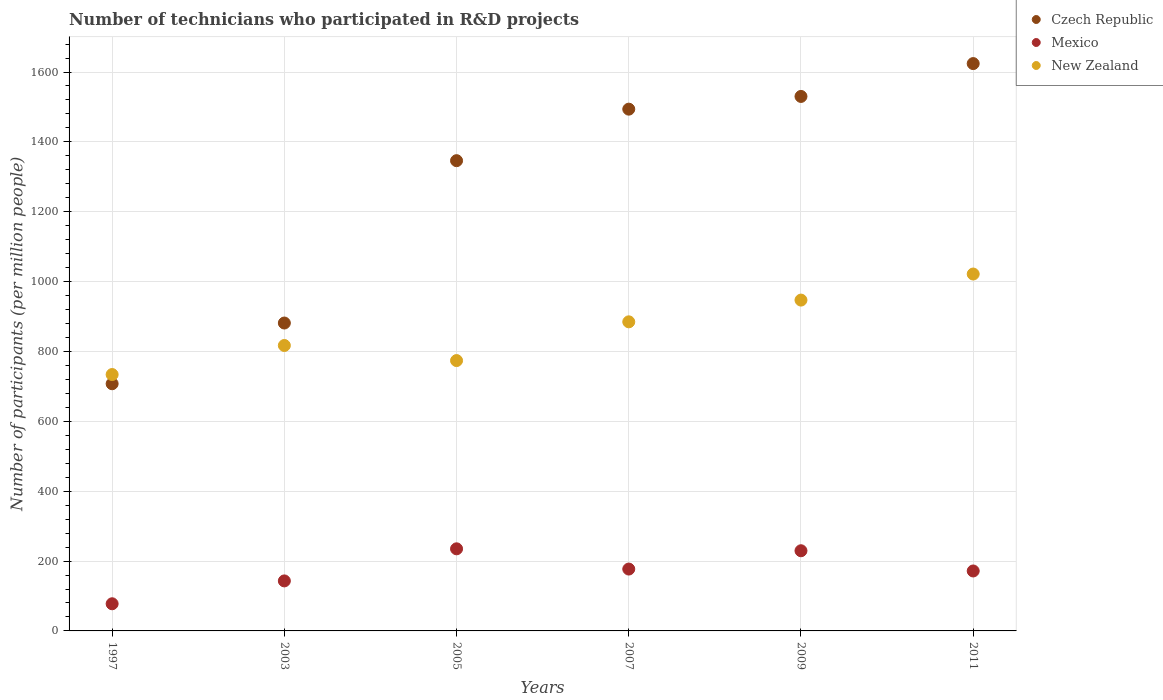Is the number of dotlines equal to the number of legend labels?
Provide a succinct answer. Yes. What is the number of technicians who participated in R&D projects in New Zealand in 1997?
Ensure brevity in your answer.  733.97. Across all years, what is the maximum number of technicians who participated in R&D projects in Czech Republic?
Your answer should be compact. 1624.14. Across all years, what is the minimum number of technicians who participated in R&D projects in Mexico?
Keep it short and to the point. 77.72. In which year was the number of technicians who participated in R&D projects in Mexico maximum?
Offer a very short reply. 2005. In which year was the number of technicians who participated in R&D projects in Czech Republic minimum?
Ensure brevity in your answer.  1997. What is the total number of technicians who participated in R&D projects in Mexico in the graph?
Make the answer very short. 1034.16. What is the difference between the number of technicians who participated in R&D projects in Czech Republic in 1997 and that in 2003?
Provide a succinct answer. -173.83. What is the difference between the number of technicians who participated in R&D projects in Mexico in 1997 and the number of technicians who participated in R&D projects in Czech Republic in 2005?
Provide a short and direct response. -1268.46. What is the average number of technicians who participated in R&D projects in Czech Republic per year?
Ensure brevity in your answer.  1263.85. In the year 2003, what is the difference between the number of technicians who participated in R&D projects in New Zealand and number of technicians who participated in R&D projects in Mexico?
Give a very brief answer. 673.95. In how many years, is the number of technicians who participated in R&D projects in New Zealand greater than 1280?
Your answer should be very brief. 0. What is the ratio of the number of technicians who participated in R&D projects in Mexico in 1997 to that in 2009?
Your response must be concise. 0.34. Is the number of technicians who participated in R&D projects in Mexico in 1997 less than that in 2011?
Give a very brief answer. Yes. What is the difference between the highest and the second highest number of technicians who participated in R&D projects in Czech Republic?
Your response must be concise. 94.04. What is the difference between the highest and the lowest number of technicians who participated in R&D projects in New Zealand?
Make the answer very short. 287.72. Is it the case that in every year, the sum of the number of technicians who participated in R&D projects in Mexico and number of technicians who participated in R&D projects in New Zealand  is greater than the number of technicians who participated in R&D projects in Czech Republic?
Provide a short and direct response. No. Is the number of technicians who participated in R&D projects in Czech Republic strictly greater than the number of technicians who participated in R&D projects in New Zealand over the years?
Offer a terse response. No. How many dotlines are there?
Make the answer very short. 3. Does the graph contain grids?
Make the answer very short. Yes. How many legend labels are there?
Your answer should be compact. 3. What is the title of the graph?
Ensure brevity in your answer.  Number of technicians who participated in R&D projects. Does "Bulgaria" appear as one of the legend labels in the graph?
Give a very brief answer. No. What is the label or title of the X-axis?
Offer a terse response. Years. What is the label or title of the Y-axis?
Make the answer very short. Number of participants (per million people). What is the Number of participants (per million people) of Czech Republic in 1997?
Your answer should be very brief. 707.59. What is the Number of participants (per million people) of Mexico in 1997?
Provide a succinct answer. 77.72. What is the Number of participants (per million people) in New Zealand in 1997?
Your response must be concise. 733.97. What is the Number of participants (per million people) of Czech Republic in 2003?
Give a very brief answer. 881.43. What is the Number of participants (per million people) in Mexico in 2003?
Make the answer very short. 143.18. What is the Number of participants (per million people) of New Zealand in 2003?
Provide a short and direct response. 817.12. What is the Number of participants (per million people) in Czech Republic in 2005?
Provide a short and direct response. 1346.19. What is the Number of participants (per million people) of Mexico in 2005?
Offer a very short reply. 235.05. What is the Number of participants (per million people) in New Zealand in 2005?
Provide a short and direct response. 773.94. What is the Number of participants (per million people) in Czech Republic in 2007?
Offer a very short reply. 1493.68. What is the Number of participants (per million people) in Mexico in 2007?
Your answer should be very brief. 177.1. What is the Number of participants (per million people) in New Zealand in 2007?
Offer a very short reply. 884.85. What is the Number of participants (per million people) of Czech Republic in 2009?
Give a very brief answer. 1530.09. What is the Number of participants (per million people) in Mexico in 2009?
Your answer should be compact. 229.5. What is the Number of participants (per million people) in New Zealand in 2009?
Keep it short and to the point. 947.07. What is the Number of participants (per million people) in Czech Republic in 2011?
Ensure brevity in your answer.  1624.14. What is the Number of participants (per million people) in Mexico in 2011?
Offer a very short reply. 171.61. What is the Number of participants (per million people) of New Zealand in 2011?
Your response must be concise. 1021.69. Across all years, what is the maximum Number of participants (per million people) of Czech Republic?
Your answer should be very brief. 1624.14. Across all years, what is the maximum Number of participants (per million people) of Mexico?
Ensure brevity in your answer.  235.05. Across all years, what is the maximum Number of participants (per million people) of New Zealand?
Your response must be concise. 1021.69. Across all years, what is the minimum Number of participants (per million people) in Czech Republic?
Offer a very short reply. 707.59. Across all years, what is the minimum Number of participants (per million people) in Mexico?
Your answer should be very brief. 77.72. Across all years, what is the minimum Number of participants (per million people) of New Zealand?
Your answer should be very brief. 733.97. What is the total Number of participants (per million people) in Czech Republic in the graph?
Offer a terse response. 7583.12. What is the total Number of participants (per million people) in Mexico in the graph?
Keep it short and to the point. 1034.16. What is the total Number of participants (per million people) in New Zealand in the graph?
Your response must be concise. 5178.64. What is the difference between the Number of participants (per million people) in Czech Republic in 1997 and that in 2003?
Your answer should be very brief. -173.83. What is the difference between the Number of participants (per million people) of Mexico in 1997 and that in 2003?
Your response must be concise. -65.46. What is the difference between the Number of participants (per million people) in New Zealand in 1997 and that in 2003?
Offer a very short reply. -83.16. What is the difference between the Number of participants (per million people) of Czech Republic in 1997 and that in 2005?
Your answer should be compact. -638.59. What is the difference between the Number of participants (per million people) of Mexico in 1997 and that in 2005?
Your answer should be compact. -157.33. What is the difference between the Number of participants (per million people) in New Zealand in 1997 and that in 2005?
Your response must be concise. -39.97. What is the difference between the Number of participants (per million people) of Czech Republic in 1997 and that in 2007?
Offer a very short reply. -786.09. What is the difference between the Number of participants (per million people) in Mexico in 1997 and that in 2007?
Offer a very short reply. -99.38. What is the difference between the Number of participants (per million people) of New Zealand in 1997 and that in 2007?
Provide a short and direct response. -150.88. What is the difference between the Number of participants (per million people) of Czech Republic in 1997 and that in 2009?
Make the answer very short. -822.5. What is the difference between the Number of participants (per million people) in Mexico in 1997 and that in 2009?
Provide a succinct answer. -151.78. What is the difference between the Number of participants (per million people) of New Zealand in 1997 and that in 2009?
Your response must be concise. -213.11. What is the difference between the Number of participants (per million people) of Czech Republic in 1997 and that in 2011?
Give a very brief answer. -916.54. What is the difference between the Number of participants (per million people) of Mexico in 1997 and that in 2011?
Your response must be concise. -93.89. What is the difference between the Number of participants (per million people) in New Zealand in 1997 and that in 2011?
Provide a short and direct response. -287.72. What is the difference between the Number of participants (per million people) in Czech Republic in 2003 and that in 2005?
Make the answer very short. -464.76. What is the difference between the Number of participants (per million people) in Mexico in 2003 and that in 2005?
Your answer should be very brief. -91.87. What is the difference between the Number of participants (per million people) in New Zealand in 2003 and that in 2005?
Provide a succinct answer. 43.19. What is the difference between the Number of participants (per million people) of Czech Republic in 2003 and that in 2007?
Your answer should be compact. -612.25. What is the difference between the Number of participants (per million people) in Mexico in 2003 and that in 2007?
Ensure brevity in your answer.  -33.92. What is the difference between the Number of participants (per million people) in New Zealand in 2003 and that in 2007?
Your answer should be compact. -67.72. What is the difference between the Number of participants (per million people) of Czech Republic in 2003 and that in 2009?
Offer a terse response. -648.67. What is the difference between the Number of participants (per million people) in Mexico in 2003 and that in 2009?
Offer a very short reply. -86.32. What is the difference between the Number of participants (per million people) of New Zealand in 2003 and that in 2009?
Provide a short and direct response. -129.95. What is the difference between the Number of participants (per million people) in Czech Republic in 2003 and that in 2011?
Provide a short and direct response. -742.71. What is the difference between the Number of participants (per million people) of Mexico in 2003 and that in 2011?
Offer a terse response. -28.44. What is the difference between the Number of participants (per million people) in New Zealand in 2003 and that in 2011?
Offer a terse response. -204.56. What is the difference between the Number of participants (per million people) of Czech Republic in 2005 and that in 2007?
Ensure brevity in your answer.  -147.5. What is the difference between the Number of participants (per million people) of Mexico in 2005 and that in 2007?
Ensure brevity in your answer.  57.95. What is the difference between the Number of participants (per million people) in New Zealand in 2005 and that in 2007?
Make the answer very short. -110.91. What is the difference between the Number of participants (per million people) of Czech Republic in 2005 and that in 2009?
Your answer should be very brief. -183.91. What is the difference between the Number of participants (per million people) of Mexico in 2005 and that in 2009?
Your response must be concise. 5.55. What is the difference between the Number of participants (per million people) of New Zealand in 2005 and that in 2009?
Offer a very short reply. -173.14. What is the difference between the Number of participants (per million people) in Czech Republic in 2005 and that in 2011?
Keep it short and to the point. -277.95. What is the difference between the Number of participants (per million people) in Mexico in 2005 and that in 2011?
Offer a terse response. 63.43. What is the difference between the Number of participants (per million people) in New Zealand in 2005 and that in 2011?
Offer a very short reply. -247.75. What is the difference between the Number of participants (per million people) in Czech Republic in 2007 and that in 2009?
Offer a very short reply. -36.41. What is the difference between the Number of participants (per million people) of Mexico in 2007 and that in 2009?
Ensure brevity in your answer.  -52.4. What is the difference between the Number of participants (per million people) in New Zealand in 2007 and that in 2009?
Your answer should be very brief. -62.23. What is the difference between the Number of participants (per million people) in Czech Republic in 2007 and that in 2011?
Your answer should be compact. -130.45. What is the difference between the Number of participants (per million people) of Mexico in 2007 and that in 2011?
Your answer should be very brief. 5.49. What is the difference between the Number of participants (per million people) of New Zealand in 2007 and that in 2011?
Your answer should be very brief. -136.84. What is the difference between the Number of participants (per million people) of Czech Republic in 2009 and that in 2011?
Offer a terse response. -94.04. What is the difference between the Number of participants (per million people) in Mexico in 2009 and that in 2011?
Provide a succinct answer. 57.88. What is the difference between the Number of participants (per million people) of New Zealand in 2009 and that in 2011?
Make the answer very short. -74.61. What is the difference between the Number of participants (per million people) of Czech Republic in 1997 and the Number of participants (per million people) of Mexico in 2003?
Your response must be concise. 564.42. What is the difference between the Number of participants (per million people) of Czech Republic in 1997 and the Number of participants (per million people) of New Zealand in 2003?
Offer a very short reply. -109.53. What is the difference between the Number of participants (per million people) of Mexico in 1997 and the Number of participants (per million people) of New Zealand in 2003?
Your response must be concise. -739.4. What is the difference between the Number of participants (per million people) of Czech Republic in 1997 and the Number of participants (per million people) of Mexico in 2005?
Your answer should be compact. 472.55. What is the difference between the Number of participants (per million people) of Czech Republic in 1997 and the Number of participants (per million people) of New Zealand in 2005?
Provide a short and direct response. -66.34. What is the difference between the Number of participants (per million people) of Mexico in 1997 and the Number of participants (per million people) of New Zealand in 2005?
Offer a very short reply. -696.22. What is the difference between the Number of participants (per million people) of Czech Republic in 1997 and the Number of participants (per million people) of Mexico in 2007?
Your answer should be compact. 530.49. What is the difference between the Number of participants (per million people) in Czech Republic in 1997 and the Number of participants (per million people) in New Zealand in 2007?
Keep it short and to the point. -177.25. What is the difference between the Number of participants (per million people) of Mexico in 1997 and the Number of participants (per million people) of New Zealand in 2007?
Your answer should be compact. -807.12. What is the difference between the Number of participants (per million people) of Czech Republic in 1997 and the Number of participants (per million people) of Mexico in 2009?
Keep it short and to the point. 478.09. What is the difference between the Number of participants (per million people) of Czech Republic in 1997 and the Number of participants (per million people) of New Zealand in 2009?
Give a very brief answer. -239.48. What is the difference between the Number of participants (per million people) in Mexico in 1997 and the Number of participants (per million people) in New Zealand in 2009?
Your response must be concise. -869.35. What is the difference between the Number of participants (per million people) of Czech Republic in 1997 and the Number of participants (per million people) of Mexico in 2011?
Your response must be concise. 535.98. What is the difference between the Number of participants (per million people) of Czech Republic in 1997 and the Number of participants (per million people) of New Zealand in 2011?
Keep it short and to the point. -314.09. What is the difference between the Number of participants (per million people) of Mexico in 1997 and the Number of participants (per million people) of New Zealand in 2011?
Provide a short and direct response. -943.96. What is the difference between the Number of participants (per million people) of Czech Republic in 2003 and the Number of participants (per million people) of Mexico in 2005?
Offer a very short reply. 646.38. What is the difference between the Number of participants (per million people) of Czech Republic in 2003 and the Number of participants (per million people) of New Zealand in 2005?
Keep it short and to the point. 107.49. What is the difference between the Number of participants (per million people) of Mexico in 2003 and the Number of participants (per million people) of New Zealand in 2005?
Your response must be concise. -630.76. What is the difference between the Number of participants (per million people) in Czech Republic in 2003 and the Number of participants (per million people) in Mexico in 2007?
Make the answer very short. 704.33. What is the difference between the Number of participants (per million people) of Czech Republic in 2003 and the Number of participants (per million people) of New Zealand in 2007?
Offer a terse response. -3.42. What is the difference between the Number of participants (per million people) in Mexico in 2003 and the Number of participants (per million people) in New Zealand in 2007?
Offer a very short reply. -741.67. What is the difference between the Number of participants (per million people) in Czech Republic in 2003 and the Number of participants (per million people) in Mexico in 2009?
Provide a short and direct response. 651.93. What is the difference between the Number of participants (per million people) in Czech Republic in 2003 and the Number of participants (per million people) in New Zealand in 2009?
Your answer should be very brief. -65.65. What is the difference between the Number of participants (per million people) in Mexico in 2003 and the Number of participants (per million people) in New Zealand in 2009?
Your response must be concise. -803.9. What is the difference between the Number of participants (per million people) in Czech Republic in 2003 and the Number of participants (per million people) in Mexico in 2011?
Offer a very short reply. 709.81. What is the difference between the Number of participants (per million people) of Czech Republic in 2003 and the Number of participants (per million people) of New Zealand in 2011?
Your response must be concise. -140.26. What is the difference between the Number of participants (per million people) of Mexico in 2003 and the Number of participants (per million people) of New Zealand in 2011?
Offer a very short reply. -878.51. What is the difference between the Number of participants (per million people) in Czech Republic in 2005 and the Number of participants (per million people) in Mexico in 2007?
Keep it short and to the point. 1169.09. What is the difference between the Number of participants (per million people) of Czech Republic in 2005 and the Number of participants (per million people) of New Zealand in 2007?
Offer a very short reply. 461.34. What is the difference between the Number of participants (per million people) in Mexico in 2005 and the Number of participants (per million people) in New Zealand in 2007?
Your answer should be very brief. -649.8. What is the difference between the Number of participants (per million people) of Czech Republic in 2005 and the Number of participants (per million people) of Mexico in 2009?
Make the answer very short. 1116.69. What is the difference between the Number of participants (per million people) in Czech Republic in 2005 and the Number of participants (per million people) in New Zealand in 2009?
Ensure brevity in your answer.  399.11. What is the difference between the Number of participants (per million people) in Mexico in 2005 and the Number of participants (per million people) in New Zealand in 2009?
Offer a terse response. -712.03. What is the difference between the Number of participants (per million people) in Czech Republic in 2005 and the Number of participants (per million people) in Mexico in 2011?
Keep it short and to the point. 1174.57. What is the difference between the Number of participants (per million people) of Czech Republic in 2005 and the Number of participants (per million people) of New Zealand in 2011?
Ensure brevity in your answer.  324.5. What is the difference between the Number of participants (per million people) of Mexico in 2005 and the Number of participants (per million people) of New Zealand in 2011?
Your response must be concise. -786.64. What is the difference between the Number of participants (per million people) in Czech Republic in 2007 and the Number of participants (per million people) in Mexico in 2009?
Provide a succinct answer. 1264.18. What is the difference between the Number of participants (per million people) in Czech Republic in 2007 and the Number of participants (per million people) in New Zealand in 2009?
Your answer should be compact. 546.61. What is the difference between the Number of participants (per million people) in Mexico in 2007 and the Number of participants (per million people) in New Zealand in 2009?
Keep it short and to the point. -769.97. What is the difference between the Number of participants (per million people) in Czech Republic in 2007 and the Number of participants (per million people) in Mexico in 2011?
Offer a terse response. 1322.07. What is the difference between the Number of participants (per million people) of Czech Republic in 2007 and the Number of participants (per million people) of New Zealand in 2011?
Offer a terse response. 472. What is the difference between the Number of participants (per million people) in Mexico in 2007 and the Number of participants (per million people) in New Zealand in 2011?
Give a very brief answer. -844.59. What is the difference between the Number of participants (per million people) of Czech Republic in 2009 and the Number of participants (per million people) of Mexico in 2011?
Your response must be concise. 1358.48. What is the difference between the Number of participants (per million people) in Czech Republic in 2009 and the Number of participants (per million people) in New Zealand in 2011?
Keep it short and to the point. 508.41. What is the difference between the Number of participants (per million people) in Mexico in 2009 and the Number of participants (per million people) in New Zealand in 2011?
Make the answer very short. -792.19. What is the average Number of participants (per million people) in Czech Republic per year?
Make the answer very short. 1263.85. What is the average Number of participants (per million people) in Mexico per year?
Your answer should be very brief. 172.36. What is the average Number of participants (per million people) of New Zealand per year?
Ensure brevity in your answer.  863.11. In the year 1997, what is the difference between the Number of participants (per million people) in Czech Republic and Number of participants (per million people) in Mexico?
Provide a short and direct response. 629.87. In the year 1997, what is the difference between the Number of participants (per million people) in Czech Republic and Number of participants (per million people) in New Zealand?
Your answer should be very brief. -26.38. In the year 1997, what is the difference between the Number of participants (per million people) in Mexico and Number of participants (per million people) in New Zealand?
Ensure brevity in your answer.  -656.25. In the year 2003, what is the difference between the Number of participants (per million people) in Czech Republic and Number of participants (per million people) in Mexico?
Make the answer very short. 738.25. In the year 2003, what is the difference between the Number of participants (per million people) in Czech Republic and Number of participants (per million people) in New Zealand?
Keep it short and to the point. 64.3. In the year 2003, what is the difference between the Number of participants (per million people) of Mexico and Number of participants (per million people) of New Zealand?
Offer a terse response. -673.95. In the year 2005, what is the difference between the Number of participants (per million people) of Czech Republic and Number of participants (per million people) of Mexico?
Make the answer very short. 1111.14. In the year 2005, what is the difference between the Number of participants (per million people) of Czech Republic and Number of participants (per million people) of New Zealand?
Your answer should be very brief. 572.25. In the year 2005, what is the difference between the Number of participants (per million people) of Mexico and Number of participants (per million people) of New Zealand?
Provide a succinct answer. -538.89. In the year 2007, what is the difference between the Number of participants (per million people) of Czech Republic and Number of participants (per million people) of Mexico?
Keep it short and to the point. 1316.58. In the year 2007, what is the difference between the Number of participants (per million people) of Czech Republic and Number of participants (per million people) of New Zealand?
Give a very brief answer. 608.84. In the year 2007, what is the difference between the Number of participants (per million people) in Mexico and Number of participants (per million people) in New Zealand?
Ensure brevity in your answer.  -707.75. In the year 2009, what is the difference between the Number of participants (per million people) in Czech Republic and Number of participants (per million people) in Mexico?
Offer a terse response. 1300.6. In the year 2009, what is the difference between the Number of participants (per million people) of Czech Republic and Number of participants (per million people) of New Zealand?
Keep it short and to the point. 583.02. In the year 2009, what is the difference between the Number of participants (per million people) of Mexico and Number of participants (per million people) of New Zealand?
Offer a terse response. -717.58. In the year 2011, what is the difference between the Number of participants (per million people) of Czech Republic and Number of participants (per million people) of Mexico?
Give a very brief answer. 1452.52. In the year 2011, what is the difference between the Number of participants (per million people) in Czech Republic and Number of participants (per million people) in New Zealand?
Offer a very short reply. 602.45. In the year 2011, what is the difference between the Number of participants (per million people) in Mexico and Number of participants (per million people) in New Zealand?
Offer a terse response. -850.07. What is the ratio of the Number of participants (per million people) of Czech Republic in 1997 to that in 2003?
Provide a succinct answer. 0.8. What is the ratio of the Number of participants (per million people) of Mexico in 1997 to that in 2003?
Provide a short and direct response. 0.54. What is the ratio of the Number of participants (per million people) in New Zealand in 1997 to that in 2003?
Provide a succinct answer. 0.9. What is the ratio of the Number of participants (per million people) in Czech Republic in 1997 to that in 2005?
Provide a succinct answer. 0.53. What is the ratio of the Number of participants (per million people) in Mexico in 1997 to that in 2005?
Your answer should be very brief. 0.33. What is the ratio of the Number of participants (per million people) in New Zealand in 1997 to that in 2005?
Offer a terse response. 0.95. What is the ratio of the Number of participants (per million people) of Czech Republic in 1997 to that in 2007?
Ensure brevity in your answer.  0.47. What is the ratio of the Number of participants (per million people) of Mexico in 1997 to that in 2007?
Give a very brief answer. 0.44. What is the ratio of the Number of participants (per million people) of New Zealand in 1997 to that in 2007?
Ensure brevity in your answer.  0.83. What is the ratio of the Number of participants (per million people) of Czech Republic in 1997 to that in 2009?
Offer a very short reply. 0.46. What is the ratio of the Number of participants (per million people) of Mexico in 1997 to that in 2009?
Your response must be concise. 0.34. What is the ratio of the Number of participants (per million people) in New Zealand in 1997 to that in 2009?
Your answer should be very brief. 0.78. What is the ratio of the Number of participants (per million people) of Czech Republic in 1997 to that in 2011?
Your answer should be very brief. 0.44. What is the ratio of the Number of participants (per million people) of Mexico in 1997 to that in 2011?
Provide a short and direct response. 0.45. What is the ratio of the Number of participants (per million people) in New Zealand in 1997 to that in 2011?
Your answer should be compact. 0.72. What is the ratio of the Number of participants (per million people) in Czech Republic in 2003 to that in 2005?
Your answer should be very brief. 0.65. What is the ratio of the Number of participants (per million people) in Mexico in 2003 to that in 2005?
Your answer should be very brief. 0.61. What is the ratio of the Number of participants (per million people) of New Zealand in 2003 to that in 2005?
Your answer should be very brief. 1.06. What is the ratio of the Number of participants (per million people) of Czech Republic in 2003 to that in 2007?
Your answer should be very brief. 0.59. What is the ratio of the Number of participants (per million people) in Mexico in 2003 to that in 2007?
Make the answer very short. 0.81. What is the ratio of the Number of participants (per million people) of New Zealand in 2003 to that in 2007?
Your answer should be very brief. 0.92. What is the ratio of the Number of participants (per million people) in Czech Republic in 2003 to that in 2009?
Offer a very short reply. 0.58. What is the ratio of the Number of participants (per million people) in Mexico in 2003 to that in 2009?
Provide a short and direct response. 0.62. What is the ratio of the Number of participants (per million people) in New Zealand in 2003 to that in 2009?
Provide a short and direct response. 0.86. What is the ratio of the Number of participants (per million people) in Czech Republic in 2003 to that in 2011?
Make the answer very short. 0.54. What is the ratio of the Number of participants (per million people) of Mexico in 2003 to that in 2011?
Ensure brevity in your answer.  0.83. What is the ratio of the Number of participants (per million people) of New Zealand in 2003 to that in 2011?
Make the answer very short. 0.8. What is the ratio of the Number of participants (per million people) of Czech Republic in 2005 to that in 2007?
Keep it short and to the point. 0.9. What is the ratio of the Number of participants (per million people) in Mexico in 2005 to that in 2007?
Provide a short and direct response. 1.33. What is the ratio of the Number of participants (per million people) of New Zealand in 2005 to that in 2007?
Give a very brief answer. 0.87. What is the ratio of the Number of participants (per million people) of Czech Republic in 2005 to that in 2009?
Keep it short and to the point. 0.88. What is the ratio of the Number of participants (per million people) in Mexico in 2005 to that in 2009?
Give a very brief answer. 1.02. What is the ratio of the Number of participants (per million people) in New Zealand in 2005 to that in 2009?
Offer a very short reply. 0.82. What is the ratio of the Number of participants (per million people) in Czech Republic in 2005 to that in 2011?
Your response must be concise. 0.83. What is the ratio of the Number of participants (per million people) of Mexico in 2005 to that in 2011?
Ensure brevity in your answer.  1.37. What is the ratio of the Number of participants (per million people) of New Zealand in 2005 to that in 2011?
Your answer should be very brief. 0.76. What is the ratio of the Number of participants (per million people) of Czech Republic in 2007 to that in 2009?
Give a very brief answer. 0.98. What is the ratio of the Number of participants (per million people) in Mexico in 2007 to that in 2009?
Your response must be concise. 0.77. What is the ratio of the Number of participants (per million people) in New Zealand in 2007 to that in 2009?
Provide a succinct answer. 0.93. What is the ratio of the Number of participants (per million people) of Czech Republic in 2007 to that in 2011?
Your answer should be compact. 0.92. What is the ratio of the Number of participants (per million people) in Mexico in 2007 to that in 2011?
Give a very brief answer. 1.03. What is the ratio of the Number of participants (per million people) in New Zealand in 2007 to that in 2011?
Offer a terse response. 0.87. What is the ratio of the Number of participants (per million people) of Czech Republic in 2009 to that in 2011?
Provide a succinct answer. 0.94. What is the ratio of the Number of participants (per million people) in Mexico in 2009 to that in 2011?
Make the answer very short. 1.34. What is the ratio of the Number of participants (per million people) of New Zealand in 2009 to that in 2011?
Offer a terse response. 0.93. What is the difference between the highest and the second highest Number of participants (per million people) of Czech Republic?
Offer a very short reply. 94.04. What is the difference between the highest and the second highest Number of participants (per million people) of Mexico?
Keep it short and to the point. 5.55. What is the difference between the highest and the second highest Number of participants (per million people) in New Zealand?
Keep it short and to the point. 74.61. What is the difference between the highest and the lowest Number of participants (per million people) in Czech Republic?
Give a very brief answer. 916.54. What is the difference between the highest and the lowest Number of participants (per million people) in Mexico?
Offer a very short reply. 157.33. What is the difference between the highest and the lowest Number of participants (per million people) in New Zealand?
Provide a short and direct response. 287.72. 